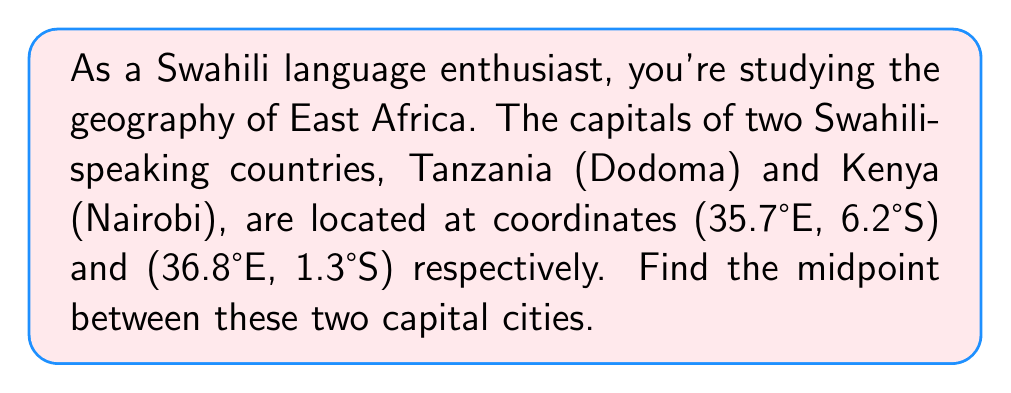Teach me how to tackle this problem. To find the midpoint between two points, we use the midpoint formula:

$$ \text{Midpoint} = \left(\frac{x_1 + x_2}{2}, \frac{y_1 + y_2}{2}\right) $$

Where $(x_1, y_1)$ is the coordinate of the first point and $(x_2, y_2)$ is the coordinate of the second point.

For Dodoma: $(x_1, y_1) = (35.7, -6.2)$
For Nairobi: $(x_2, y_2) = (36.8, -1.3)$

Note that we use negative values for the latitudes because they are in the Southern hemisphere.

Let's calculate the midpoint:

$$ x_{\text{midpoint}} = \frac{35.7 + 36.8}{2} = \frac{72.5}{2} = 36.25 $$

$$ y_{\text{midpoint}} = \frac{-6.2 + (-1.3)}{2} = \frac{-7.5}{2} = -3.75 $$

Therefore, the midpoint is $(36.25°E, 3.75°S)$.

To convert the latitude back to a positive value for the Southern hemisphere, we can simply remove the negative sign.
Answer: The midpoint between Dodoma and Nairobi is $(36.25°E, 3.75°S)$. 